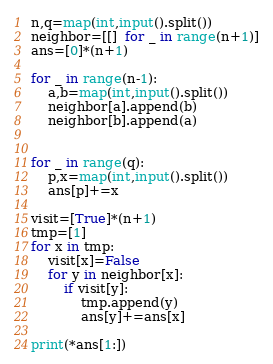<code> <loc_0><loc_0><loc_500><loc_500><_Python_>n,q=map(int,input().split())
neighbor=[[]  for _ in range(n+1)]
ans=[0]*(n+1)

for _ in range(n-1):
    a,b=map(int,input().split())
    neighbor[a].append(b)
    neighbor[b].append(a)


for _ in range(q):
    p,x=map(int,input().split())
    ans[p]+=x

visit=[True]*(n+1)
tmp=[1]
for x in tmp:
    visit[x]=False
    for y in neighbor[x]:
        if visit[y]:
            tmp.append(y)
            ans[y]+=ans[x]

print(*ans[1:])
</code> 